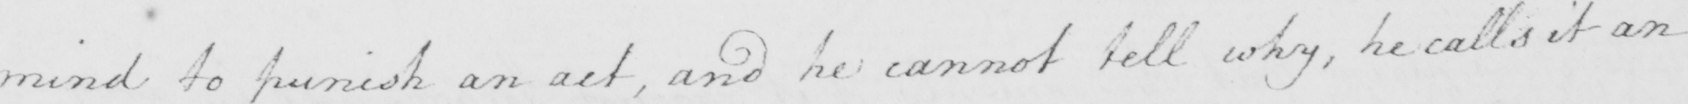Transcribe the text shown in this historical manuscript line. mind to punish an act , and he cannot tell why , he calls it an 